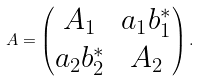Convert formula to latex. <formula><loc_0><loc_0><loc_500><loc_500>A = \begin{pmatrix} A _ { 1 } & a _ { 1 } b _ { 1 } ^ { * } \\ a _ { 2 } b _ { 2 } ^ { * } & A _ { 2 } \end{pmatrix} .</formula> 